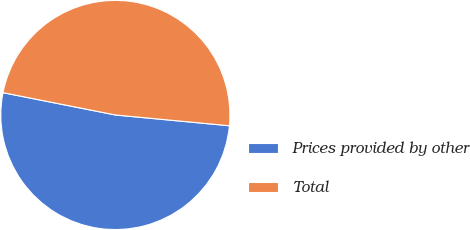Convert chart. <chart><loc_0><loc_0><loc_500><loc_500><pie_chart><fcel>Prices provided by other<fcel>Total<nl><fcel>51.62%<fcel>48.38%<nl></chart> 